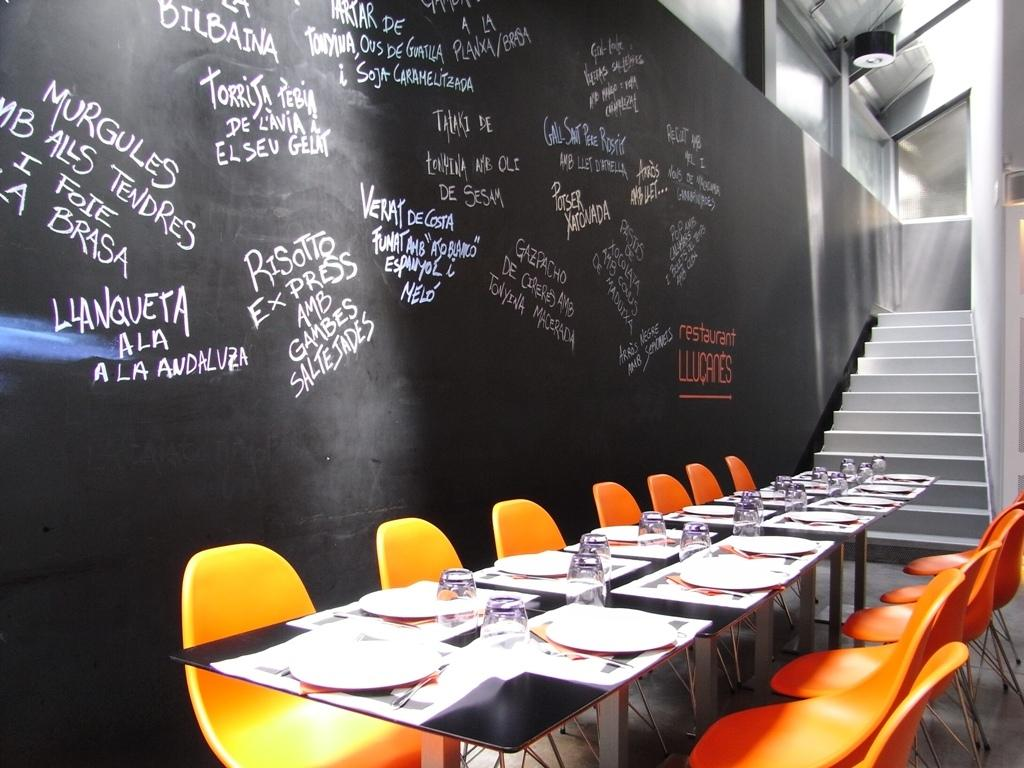What objects are on the table in the image? There are plates and glasses on the table in the image. What type of seating is located beside the table? There are orange chairs beside the table. Are there any architectural features visible in the image? Yes, there are steps visible in the image. What can be seen on the wall in the image? There is a black wall with something written on it. Can you see the seashore in the image? No, there is no seashore visible in the image. 